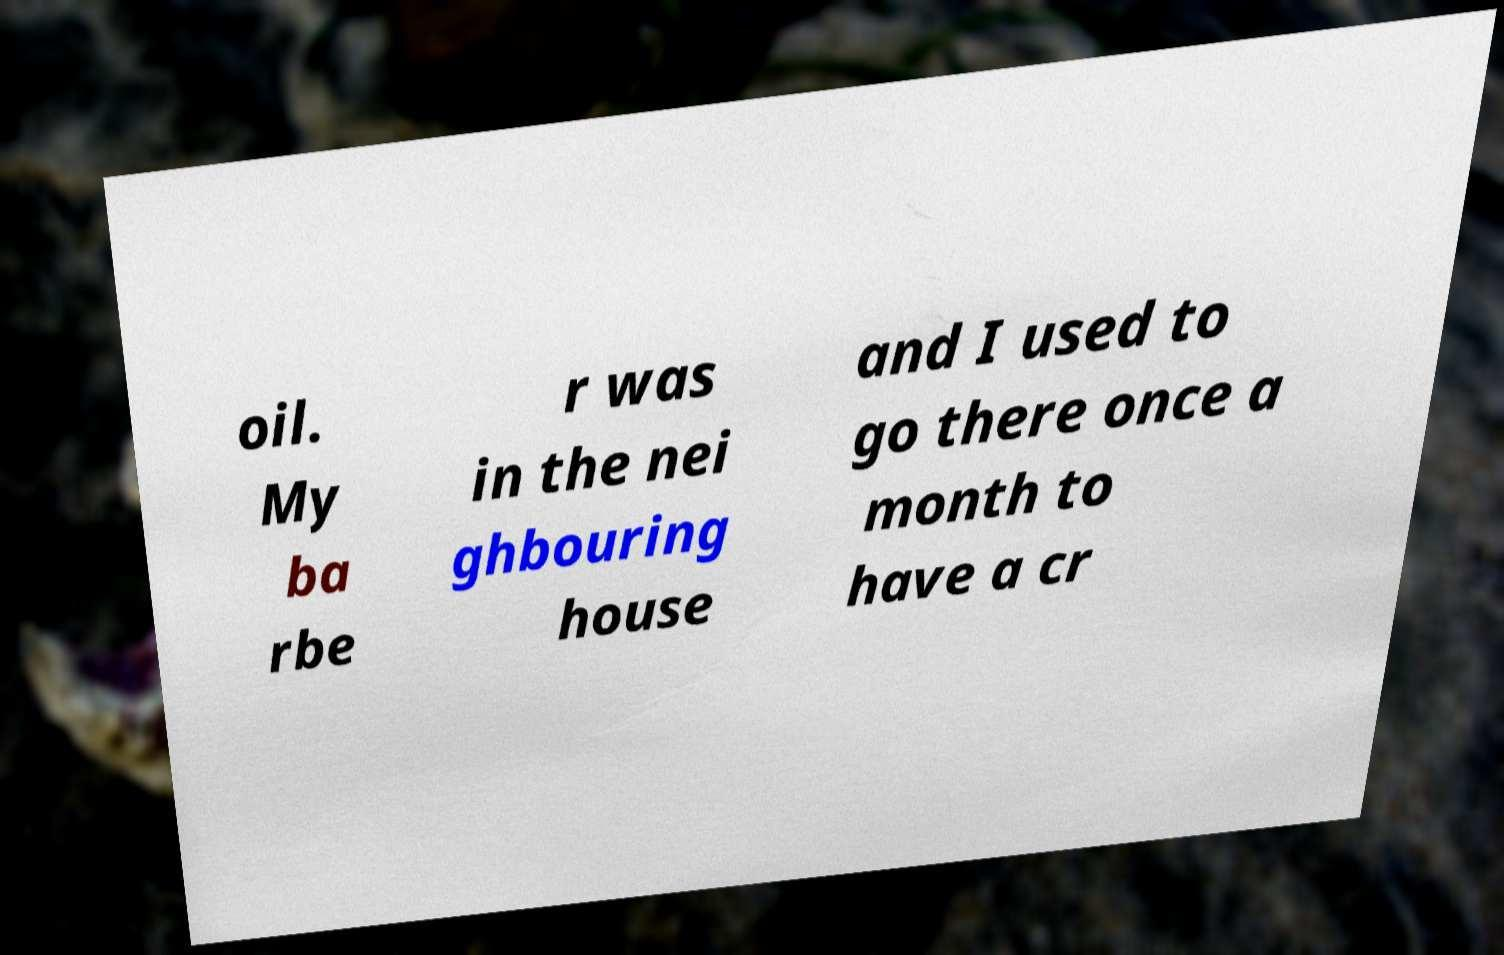Could you extract and type out the text from this image? oil. My ba rbe r was in the nei ghbouring house and I used to go there once a month to have a cr 